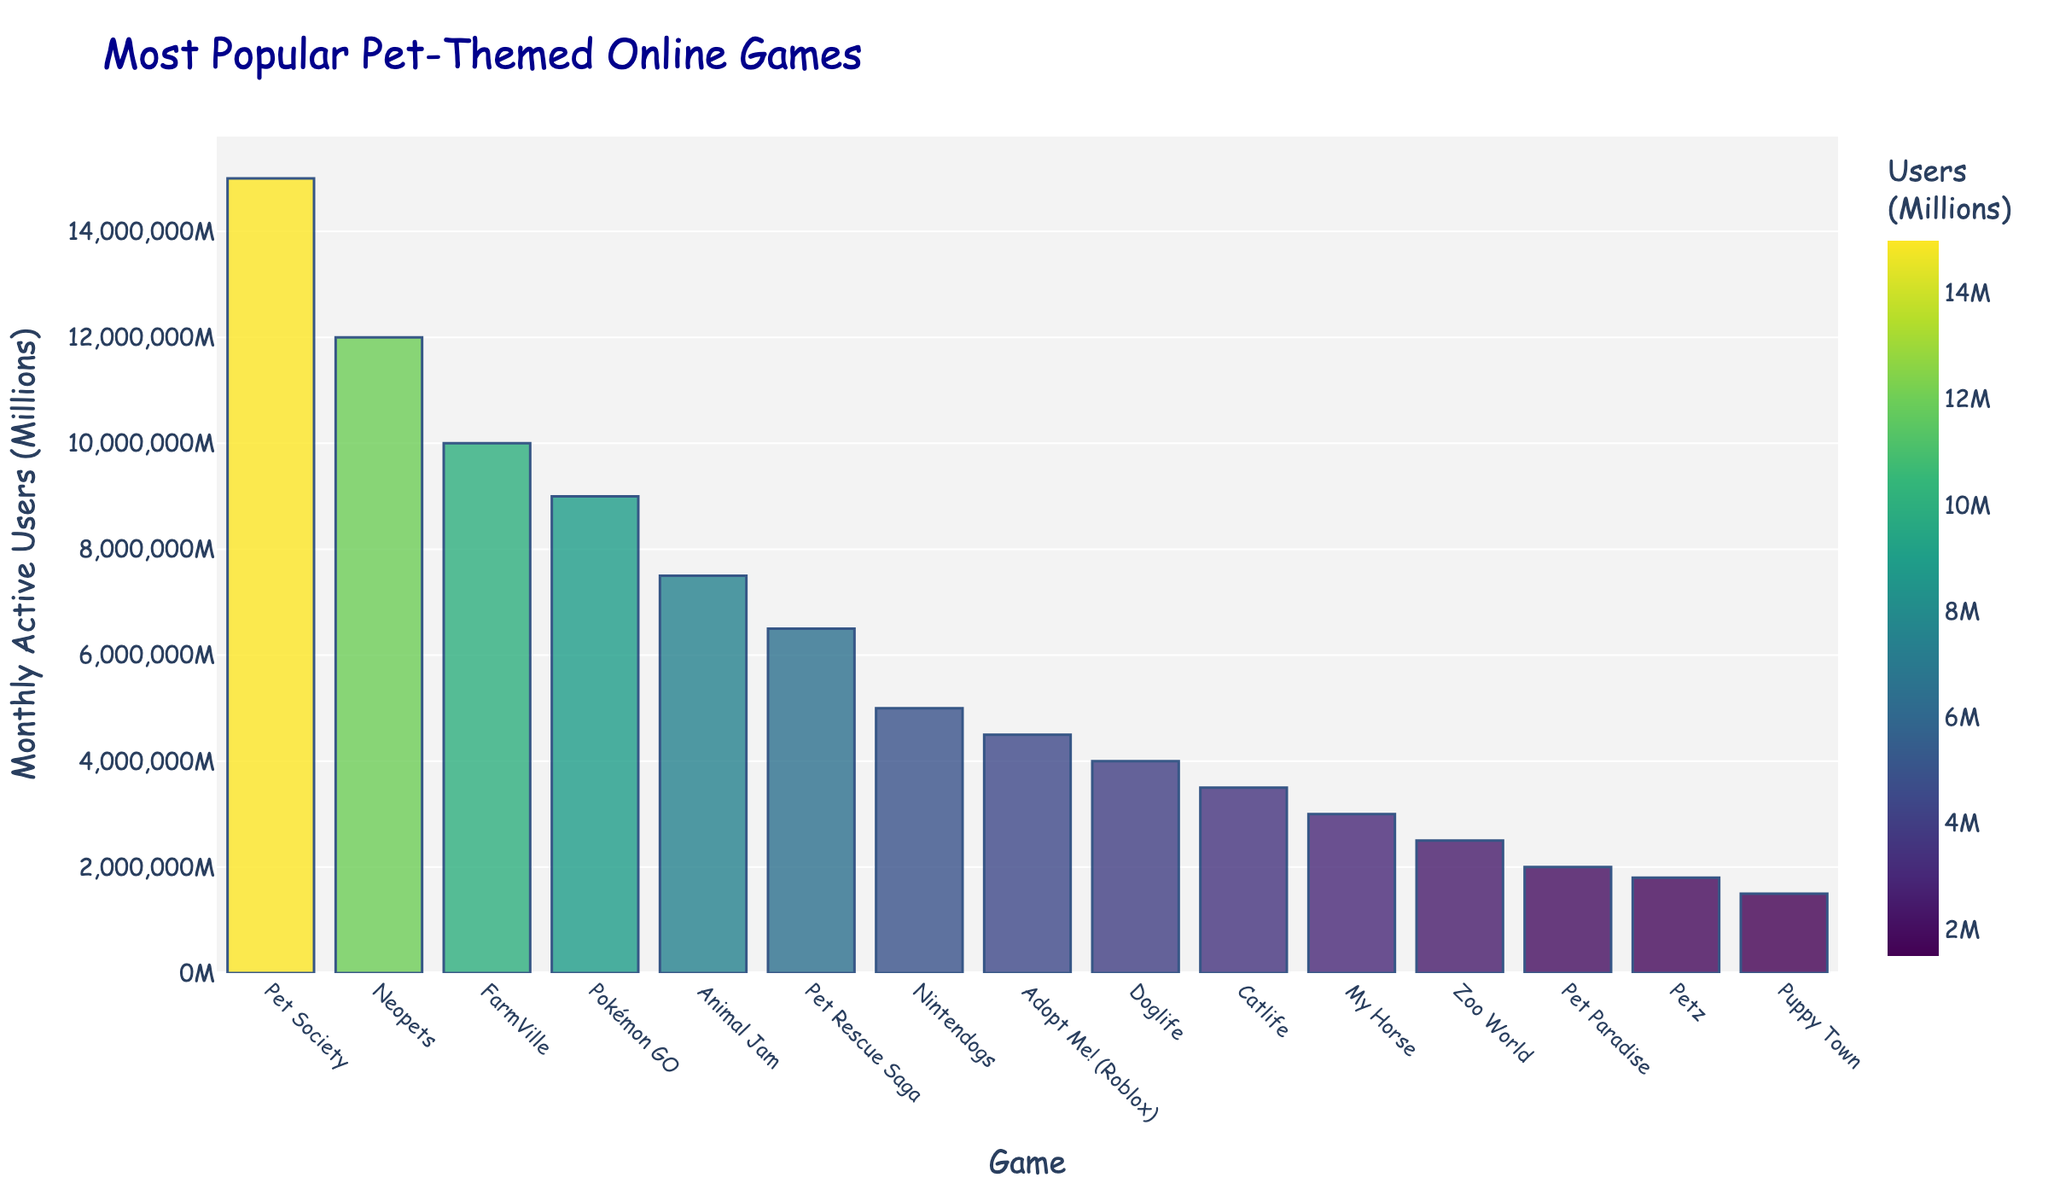What is the most popular pet-themed online game? The most popular pet-themed online game is the one with the highest monthly active users. From the figure, the tallest bar represents "Pet Society."
Answer: Pet Society Which game has more monthly active users, Neopets or Pokémon GO? To compare Neopets and Pokémon GO, check the height of their respective bars. Neopets has a taller bar (representing 12 million) compared to Pokémon GO (representing 9 million).
Answer: Neopets What is the total monthly active users for the top three games? Add the monthly active users of the top three games: Pet Society (15 million), Neopets (12 million), and FarmVille (10 million). 15 + 12 + 10 = 37 million.
Answer: 37 million What's the difference in monthly active users between Pet Society and Adopt Me! (Roblox)? Subtract the monthly active users of Adopt Me! (Roblox) from Pet Society: 15 million - 4.5 million = 10.5 million.
Answer: 10.5 million Which game has the least monthly active users, and how many users does it have? The game with the lowest bar represents the game with the least monthly active users. "Puppy Town" has the shortest bar, representing 1.5 million users.
Answer: Puppy Town, 1.5 million How many games have more than 5 million monthly active users? Count the number of bars that represent games with monthly active users greater than 5 million. There are six such games: Pet Society, Neopets, FarmVille, Pokémon GO, Animal Jam, and Pet Rescue Saga.
Answer: 6 Is the sum of monthly active users for Nintendogs and Pet Rescue Saga greater than that for Animal Jam? Calculate the sum of monthly active users for Nintendogs and Pet Rescue Saga: 5 million + 6.5 million = 11.5 million. Compare this to Animal Jam's 7.5 million. 11.5 > 7.5, so yes.
Answer: Yes What is the average number of monthly active users for the games listed? Sum the monthly active users of all games and divide by the number of games. (15 + 12 + 10 + 9 + 7.5 + 6.5 + 5 + 4.5 + 4 + 3.5 + 3 + 2.5 + 2 + 1.8 + 1.5) = 87.8 million. There are 15 games, so the average is 87.8 / 15 ≈ 5.85 million.
Answer: 5.85 million Which game has a bar colored in the darkest shade, indicating the highest number of users? The darkest shade represents the highest number of users. The darkest bar represents Pet Society.
Answer: Pet Society 